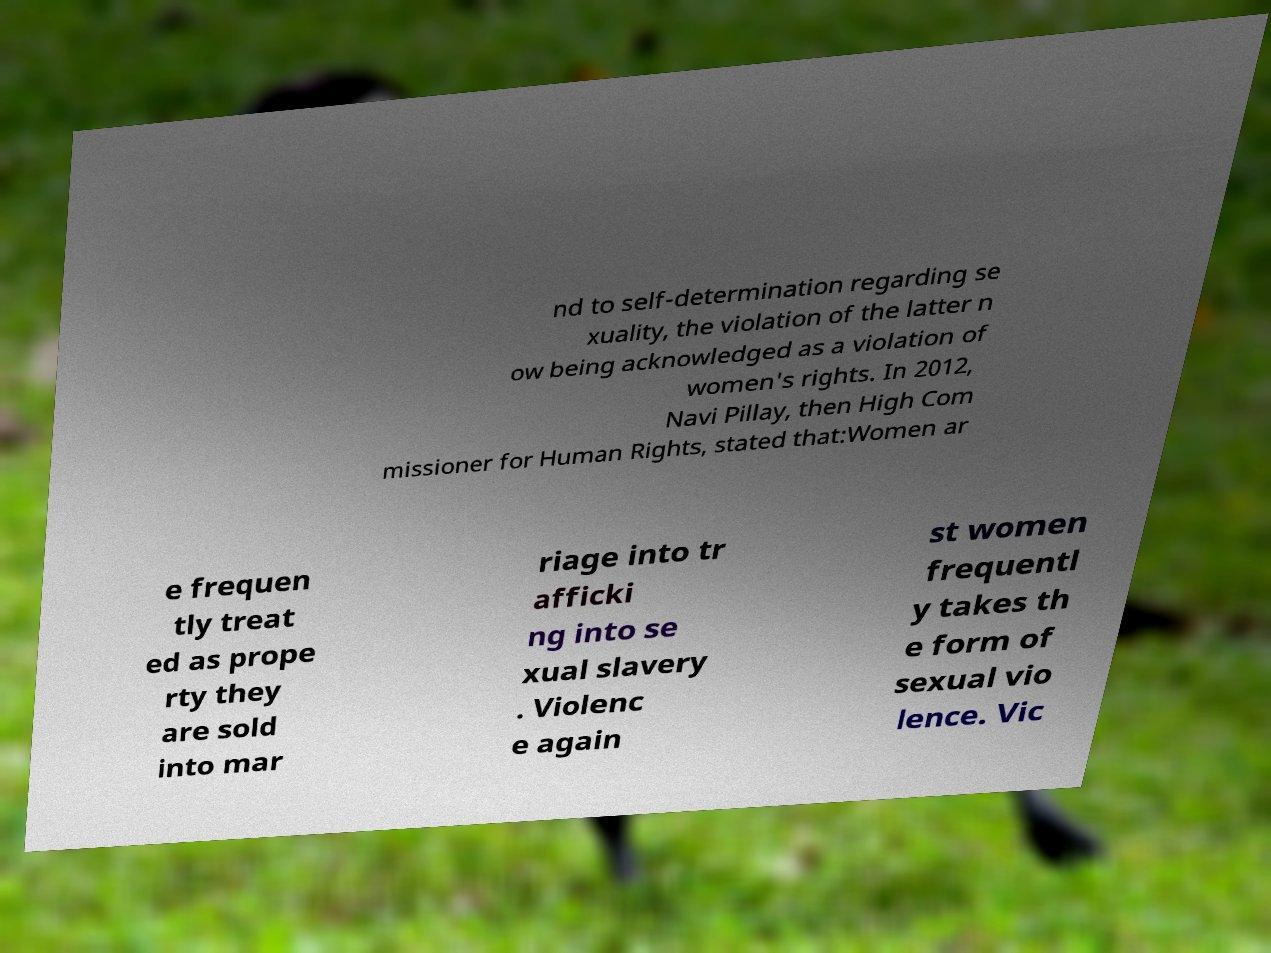Please identify and transcribe the text found in this image. nd to self-determination regarding se xuality, the violation of the latter n ow being acknowledged as a violation of women's rights. In 2012, Navi Pillay, then High Com missioner for Human Rights, stated that:Women ar e frequen tly treat ed as prope rty they are sold into mar riage into tr afficki ng into se xual slavery . Violenc e again st women frequentl y takes th e form of sexual vio lence. Vic 